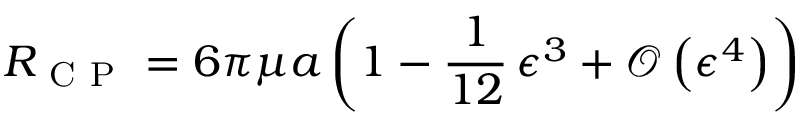Convert formula to latex. <formula><loc_0><loc_0><loc_500><loc_500>R _ { C P } = 6 \pi \mu a \left ( 1 - \frac { 1 } { 1 2 } \, \epsilon ^ { 3 } + \mathcal { O } \left ( \epsilon ^ { 4 } \right ) \right )</formula> 